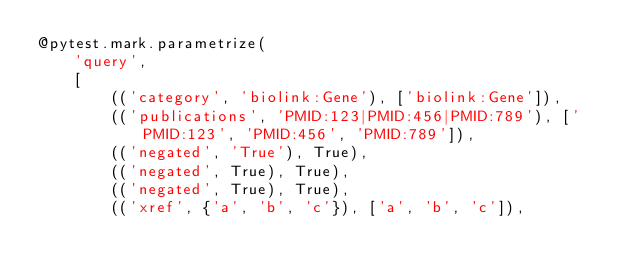<code> <loc_0><loc_0><loc_500><loc_500><_Python_>@pytest.mark.parametrize(
    'query',
    [
        (('category', 'biolink:Gene'), ['biolink:Gene']),
        (('publications', 'PMID:123|PMID:456|PMID:789'), ['PMID:123', 'PMID:456', 'PMID:789']),
        (('negated', 'True'), True),
        (('negated', True), True),
        (('negated', True), True),
        (('xref', {'a', 'b', 'c'}), ['a', 'b', 'c']),</code> 